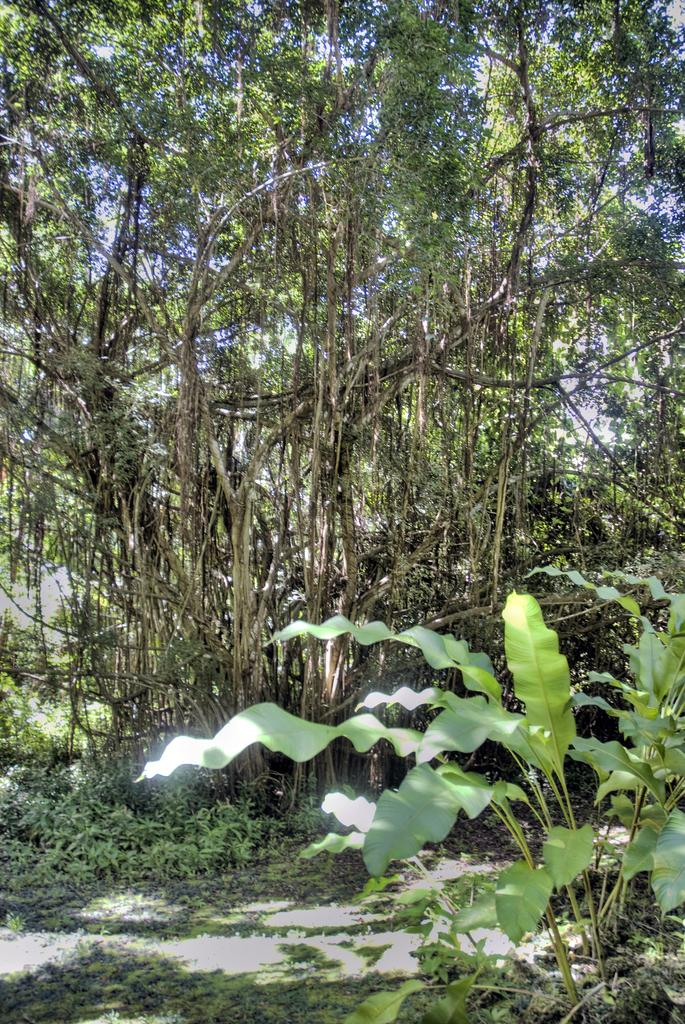What type of vegetation can be seen in the image? There are trees on the grassland in the image. Can you describe the overall landscape in the image? There are plants all over the place in the image. What color are the eyes of the rat in the image? There is no rat present in the image, so it is not possible to determine the color of its eyes. How does the feeling of the grassland make you feel when looking at the image? The image does not convey a specific feeling, as it is a visual representation of a grassland with trees and plants. 